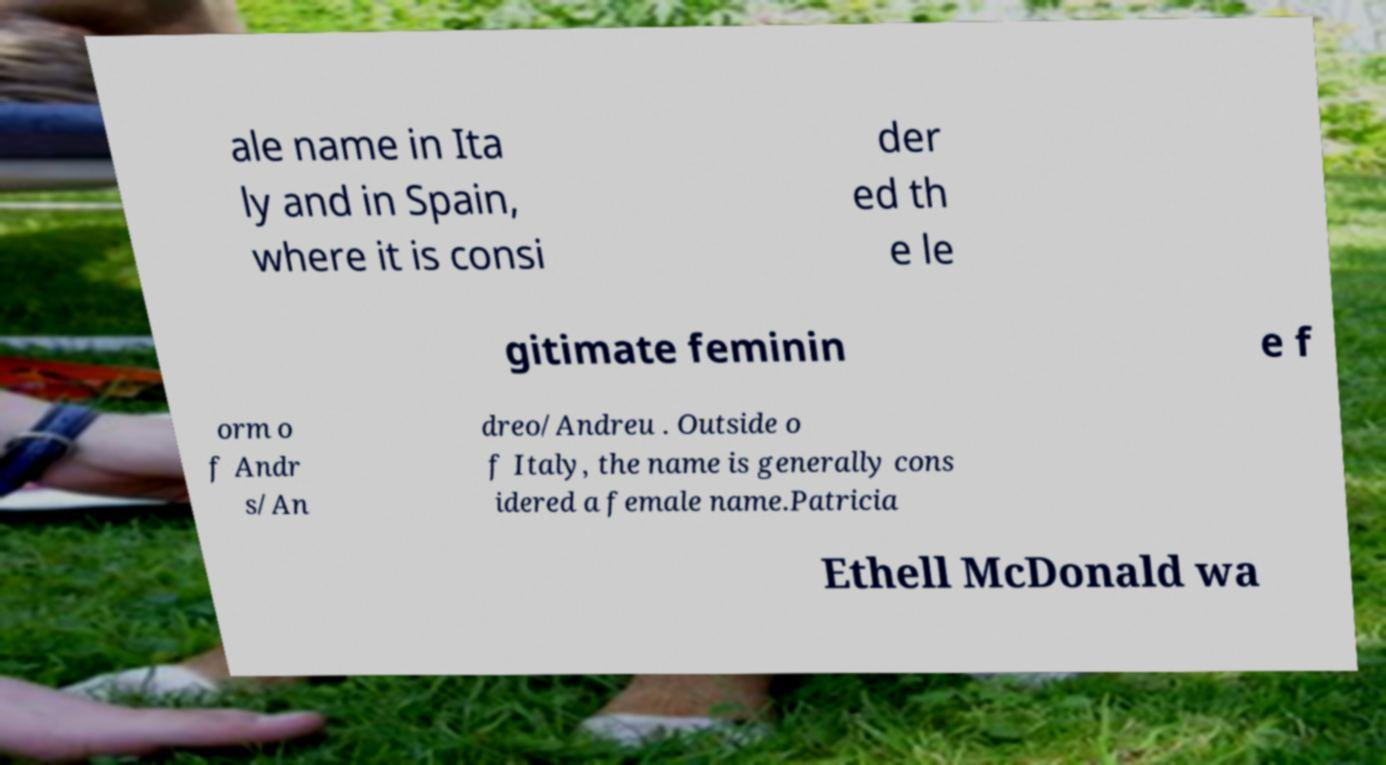For documentation purposes, I need the text within this image transcribed. Could you provide that? ale name in Ita ly and in Spain, where it is consi der ed th e le gitimate feminin e f orm o f Andr s/An dreo/Andreu . Outside o f Italy, the name is generally cons idered a female name.Patricia Ethell McDonald wa 